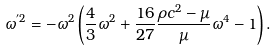<formula> <loc_0><loc_0><loc_500><loc_500>\omega ^ { ^ { \prime } 2 } = - \omega ^ { 2 } \left ( \frac { 4 } { 3 } \omega ^ { 2 } + \frac { 1 6 } { 2 7 } \frac { \rho c ^ { 2 } - \mu } { \mu } \omega ^ { 4 } - 1 \right ) .</formula> 